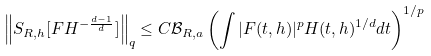<formula> <loc_0><loc_0><loc_500><loc_500>\left \| S _ { R , h } [ F H ^ { - \frac { d - 1 } d } ] \right \| _ { q } \leq C \mathcal { B } _ { R , a } \left ( \int | F ( t , h ) | ^ { p } H ( t , h ) ^ { 1 / d } d t \right ) ^ { 1 / p }</formula> 